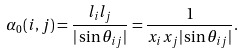Convert formula to latex. <formula><loc_0><loc_0><loc_500><loc_500>\alpha _ { 0 } ( i , j ) = \frac { l _ { i } l _ { j } } { | \sin \theta _ { i j } | } = \frac { 1 } { x _ { i } x _ { j } | \sin \theta _ { i j } | } .</formula> 